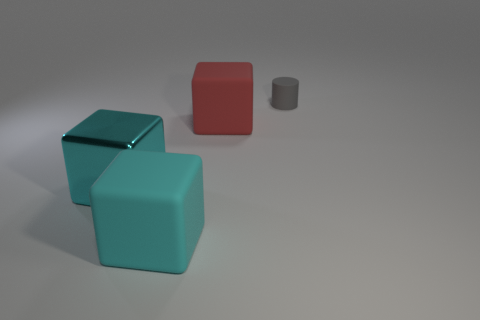Are there any other things that are the same shape as the gray thing?
Give a very brief answer. No. Does the big matte block in front of the cyan metallic object have the same color as the large metal object?
Offer a terse response. Yes. There is a thing that is to the left of the small matte cylinder and right of the large cyan matte thing; what is its material?
Keep it short and to the point. Rubber. Is the number of objects greater than the number of small rubber cylinders?
Your answer should be very brief. Yes. What color is the matte cube that is in front of the big rubber thing that is to the right of the rubber block that is left of the red block?
Offer a very short reply. Cyan. Is the material of the big thing behind the cyan metallic cube the same as the gray cylinder?
Your answer should be compact. Yes. Are there any objects of the same color as the metal cube?
Your answer should be compact. Yes. Are any big purple matte blocks visible?
Give a very brief answer. No. Is the size of the matte cube that is in front of the metal object the same as the small gray object?
Your answer should be very brief. No. Are there fewer cyan metal blocks than cyan cubes?
Offer a very short reply. Yes. 